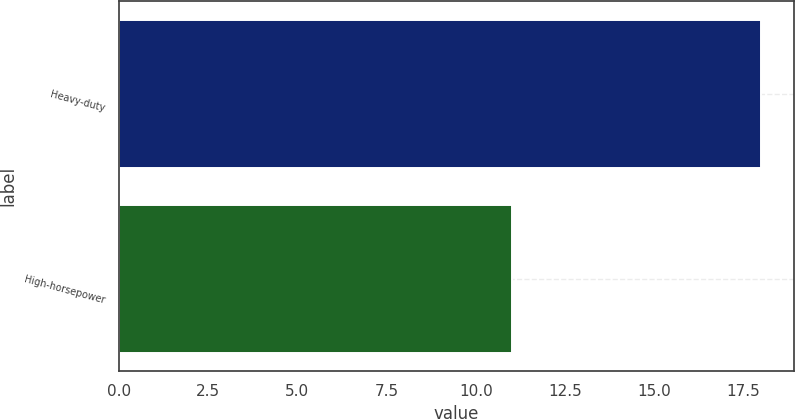Convert chart. <chart><loc_0><loc_0><loc_500><loc_500><bar_chart><fcel>Heavy-duty<fcel>High-horsepower<nl><fcel>18<fcel>11<nl></chart> 